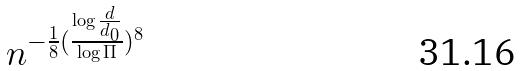<formula> <loc_0><loc_0><loc_500><loc_500>n ^ { - \frac { 1 } { 8 } ( \frac { \log \frac { d } { d _ { 0 } } } { \log \Pi } ) ^ { 8 } }</formula> 